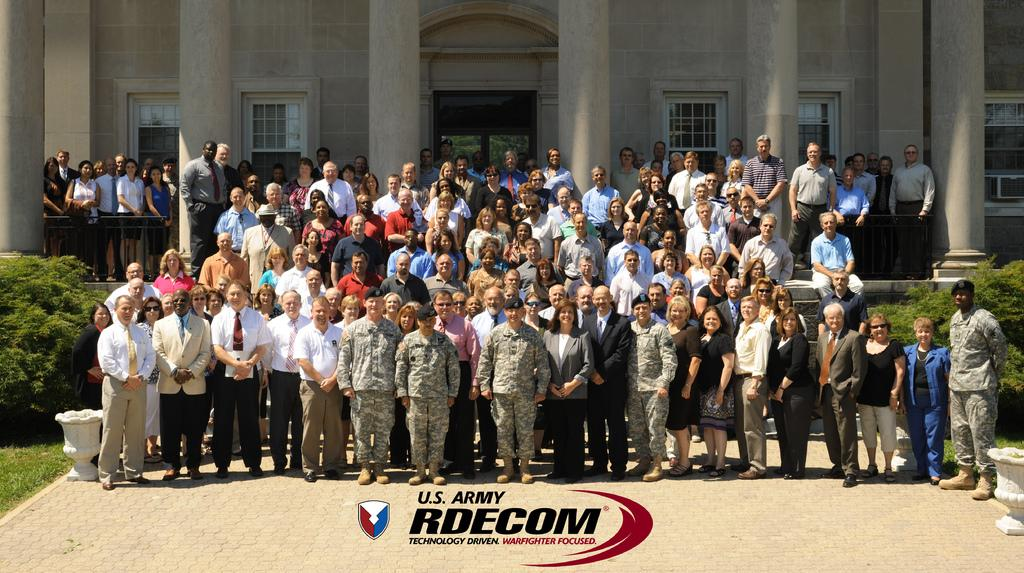How many people are in the image? There are many men and women in the image. Where are the people located in the image? The people are standing on steps. What is the main structure in the image? There is a building in the image. Can you describe the building's appearance? The building has many windows. What type of vegetation is present in the image? There are plants on either side of the building. What type of drug can be seen in the hands of the person in the image? There is no person holding a drug in the image. What type of marble is visible in the image? There is no marble present in the image. 